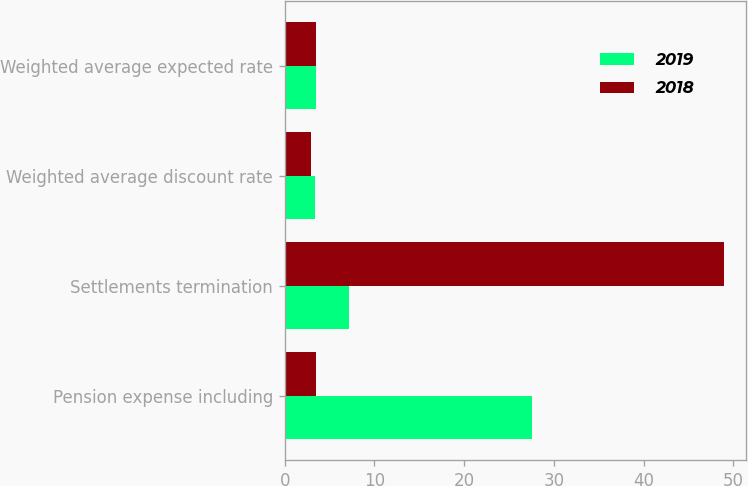Convert chart to OTSL. <chart><loc_0><loc_0><loc_500><loc_500><stacked_bar_chart><ecel><fcel>Pension expense including<fcel>Settlements termination<fcel>Weighted average discount rate<fcel>Weighted average expected rate<nl><fcel>2019<fcel>27.6<fcel>7.2<fcel>3.4<fcel>3.5<nl><fcel>2018<fcel>3.5<fcel>48.9<fcel>2.9<fcel>3.5<nl></chart> 